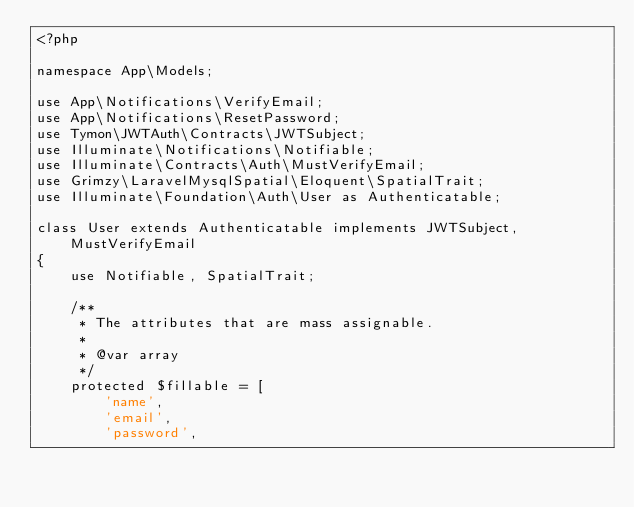<code> <loc_0><loc_0><loc_500><loc_500><_PHP_><?php

namespace App\Models;

use App\Notifications\VerifyEmail;
use App\Notifications\ResetPassword;
use Tymon\JWTAuth\Contracts\JWTSubject;
use Illuminate\Notifications\Notifiable;
use Illuminate\Contracts\Auth\MustVerifyEmail;
use Grimzy\LaravelMysqlSpatial\Eloquent\SpatialTrait;
use Illuminate\Foundation\Auth\User as Authenticatable;

class User extends Authenticatable implements JWTSubject, MustVerifyEmail
{
    use Notifiable, SpatialTrait;

    /**
     * The attributes that are mass assignable.
     *
     * @var array
     */
    protected $fillable = [
        'name',
        'email',
        'password',</code> 